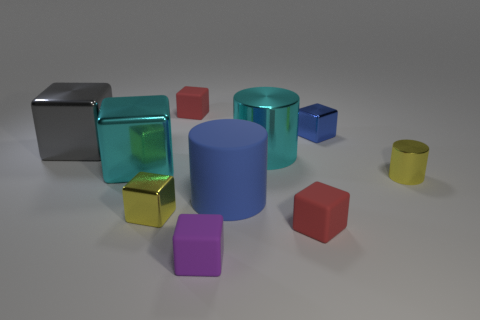What material is the small block that is both in front of the cyan metallic cube and to the right of the small purple object?
Your answer should be very brief. Rubber. There is a red matte object to the right of the tiny red matte block left of the purple matte cube; what shape is it?
Make the answer very short. Cube. Is there anything else of the same color as the rubber cylinder?
Your response must be concise. Yes. Does the yellow metal cube have the same size as the gray metallic cube that is behind the small yellow cube?
Offer a very short reply. No. How many big things are either brown rubber things or cyan objects?
Provide a short and direct response. 2. Is the number of blue blocks greater than the number of tiny metal things?
Give a very brief answer. No. There is a big cube in front of the big cyan shiny thing that is on the right side of the blue matte object; what number of big gray metallic cubes are to the right of it?
Your response must be concise. 0. What is the shape of the blue metal thing?
Provide a short and direct response. Cube. What number of other objects are the same material as the tiny yellow cylinder?
Ensure brevity in your answer.  5. Does the blue metal object have the same size as the yellow block?
Ensure brevity in your answer.  Yes. 